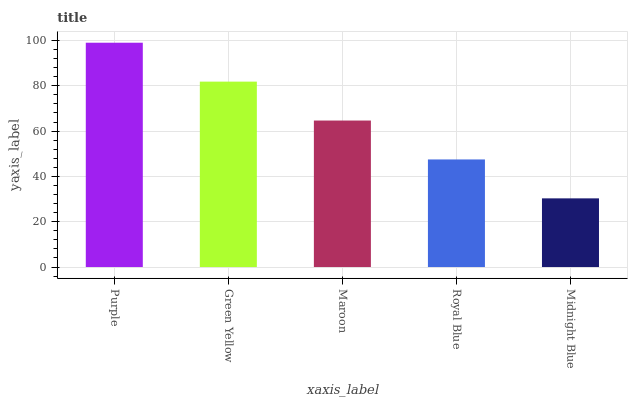Is Green Yellow the minimum?
Answer yes or no. No. Is Green Yellow the maximum?
Answer yes or no. No. Is Purple greater than Green Yellow?
Answer yes or no. Yes. Is Green Yellow less than Purple?
Answer yes or no. Yes. Is Green Yellow greater than Purple?
Answer yes or no. No. Is Purple less than Green Yellow?
Answer yes or no. No. Is Maroon the high median?
Answer yes or no. Yes. Is Maroon the low median?
Answer yes or no. Yes. Is Green Yellow the high median?
Answer yes or no. No. Is Green Yellow the low median?
Answer yes or no. No. 